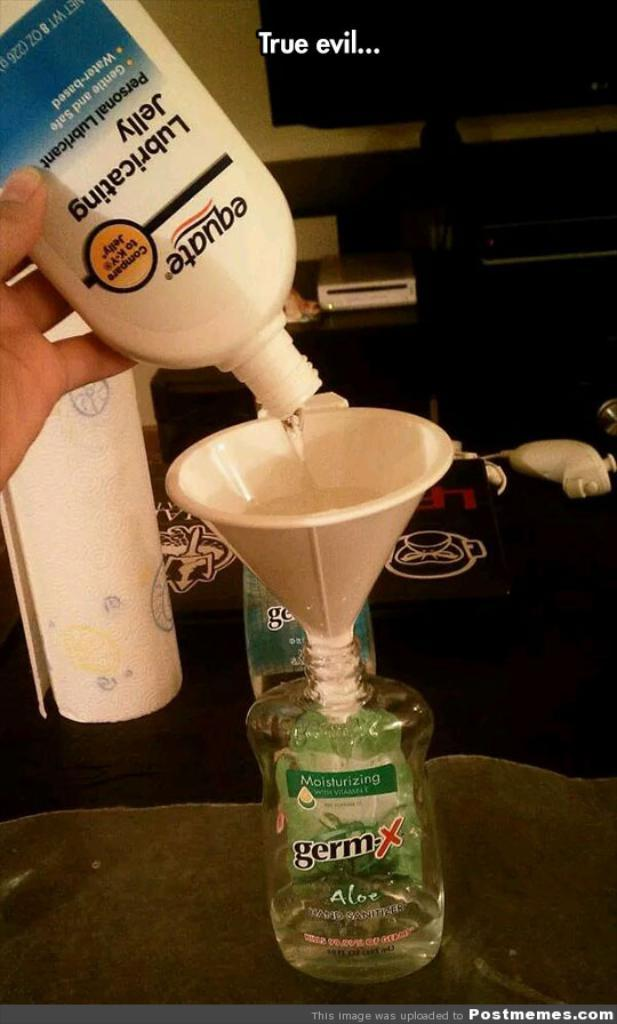Provide a one-sentence caption for the provided image. Someone is refilleing a GermX bottle with lube. 